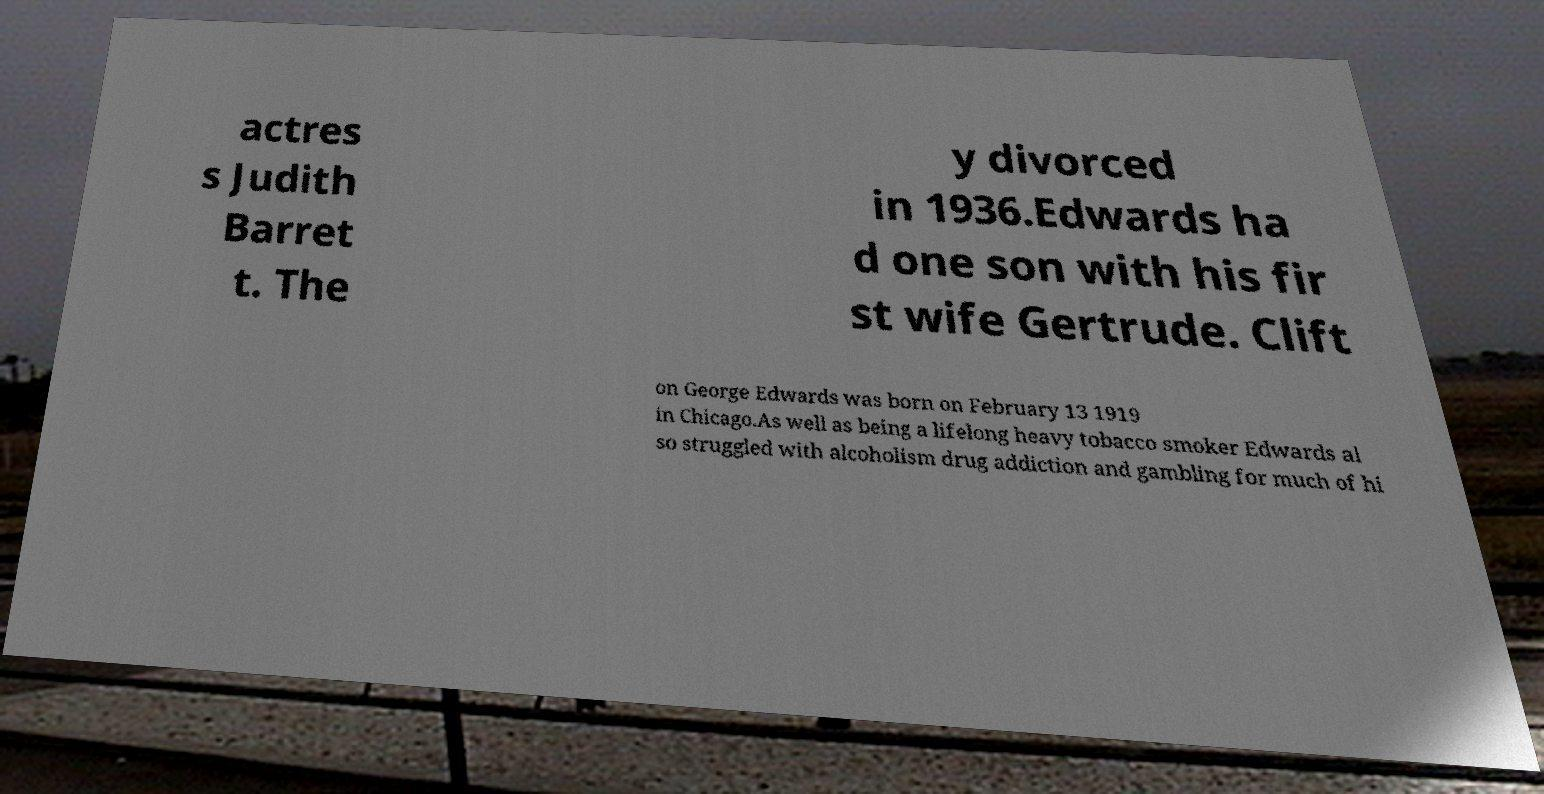Please identify and transcribe the text found in this image. actres s Judith Barret t. The y divorced in 1936.Edwards ha d one son with his fir st wife Gertrude. Clift on George Edwards was born on February 13 1919 in Chicago.As well as being a lifelong heavy tobacco smoker Edwards al so struggled with alcoholism drug addiction and gambling for much of hi 